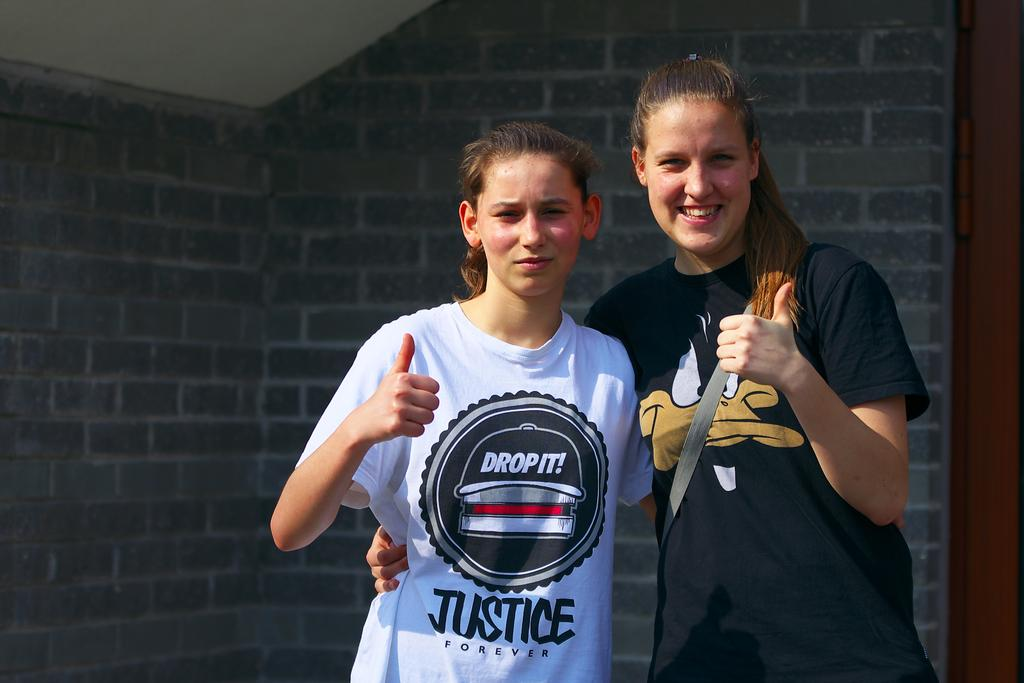<image>
Share a concise interpretation of the image provided. Two girls are standing next to each other with their thumbs up and one has a shirt that says Justice forever. 